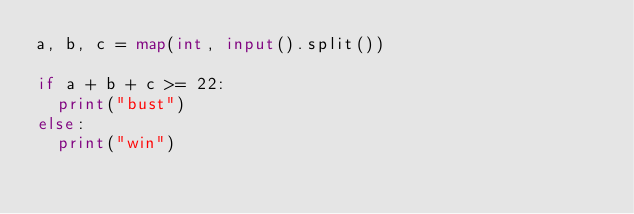<code> <loc_0><loc_0><loc_500><loc_500><_Python_>a, b, c = map(int, input().split())

if a + b + c >= 22:
  print("bust")
else:
  print("win")</code> 